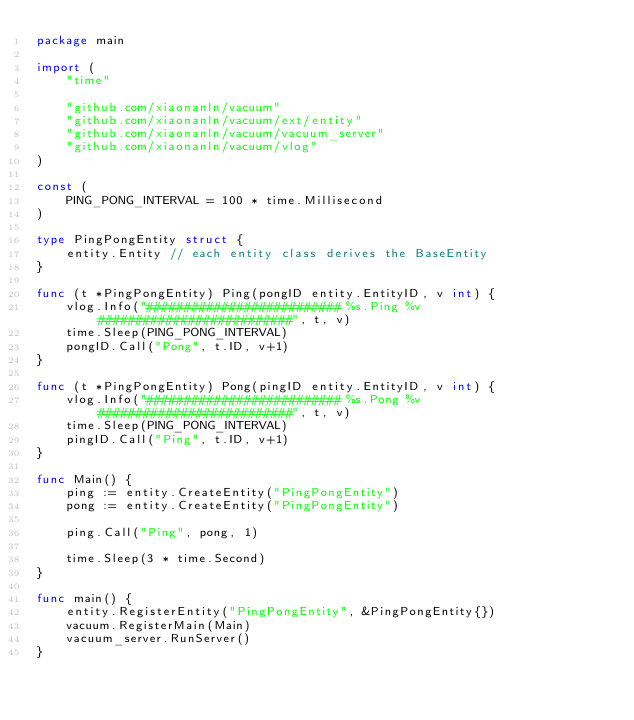<code> <loc_0><loc_0><loc_500><loc_500><_Go_>package main

import (
	"time"

	"github.com/xiaonanln/vacuum"
	"github.com/xiaonanln/vacuum/ext/entity"
	"github.com/xiaonanln/vacuum/vacuum_server"
	"github.com/xiaonanln/vacuum/vlog"
)

const (
	PING_PONG_INTERVAL = 100 * time.Millisecond
)

type PingPongEntity struct {
	entity.Entity // each entity class derives the BaseEntity
}

func (t *PingPongEntity) Ping(pongID entity.EntityID, v int) {
	vlog.Info("########################## %s.Ping %v ##########################", t, v)
	time.Sleep(PING_PONG_INTERVAL)
	pongID.Call("Pong", t.ID, v+1)
}

func (t *PingPongEntity) Pong(pingID entity.EntityID, v int) {
	vlog.Info("########################## %s.Pong %v ##########################", t, v)
	time.Sleep(PING_PONG_INTERVAL)
	pingID.Call("Ping", t.ID, v+1)
}

func Main() {
	ping := entity.CreateEntity("PingPongEntity")
	pong := entity.CreateEntity("PingPongEntity")

	ping.Call("Ping", pong, 1)

	time.Sleep(3 * time.Second)
}

func main() {
	entity.RegisterEntity("PingPongEntity", &PingPongEntity{})
	vacuum.RegisterMain(Main)
	vacuum_server.RunServer()
}
</code> 